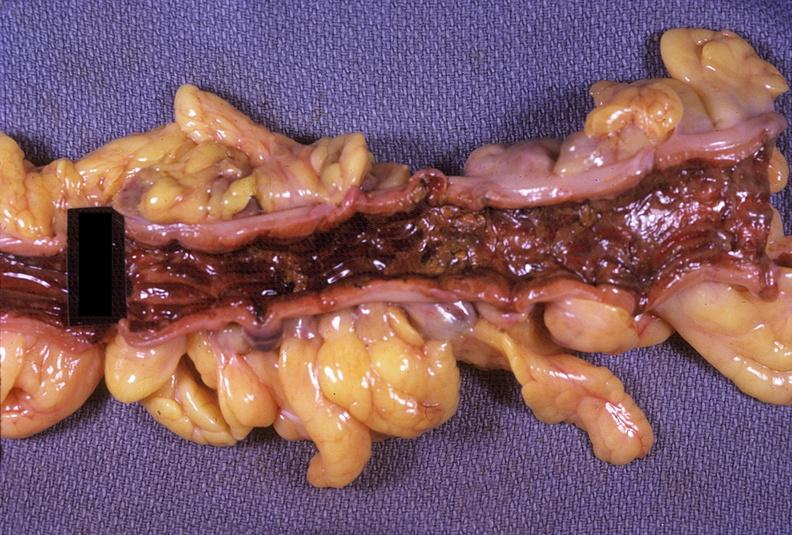s gastrointestinal present?
Answer the question using a single word or phrase. Yes 